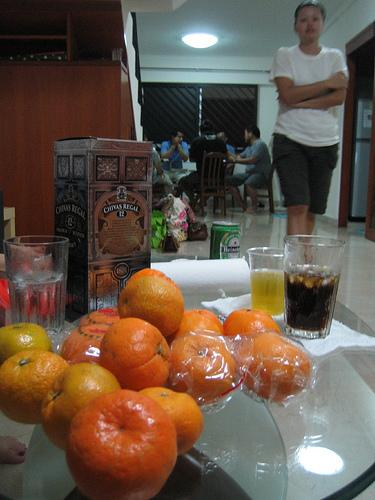The woman is doing what? crossing arms 